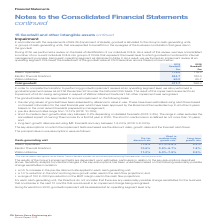According to Spirax Sarco Engineering Plc's financial document, What was consolidated as a result of the review on the basis of identification of the individual CGUs? a number of our current individual CGUs into groups of CGUs that represent the lowest level to which goodwill is monitored for internal management purposes, being each operating segment as disclosed in Note 3. The document states: "As a result of this review, we have consolidated a number of our current individual CGUs into groups of CGUs that represent the lowest level to which ..." Also, How are the carrying values of goodwill estimated? using cash flows based on forecast information for the next financial year which have been approved by the Board and then extended up to a further 9 years based on the most recent forecasts prepared by management. The document states: "erence to value in use. These have been estimated using cash flows based on forecast information for the next financial year which have been approved ..." Also, What are the different operating segment as part of the goodwill impairment reviews? The document contains multiple relevant values: Steam Specialties, Electric Thermal Solutions, Watson-Marlow. From the document: "2018 Goodwill £m Steam Specialties 113.0 119.3 Electric Thermal Solutions 244.7 183.0 Watson-Marlow 60.0 65.7 Total goodwill 417.7 368 13.0 119.3 Elec..." Additionally, In which year was the amount of Goodwill for Watson-Marlow larger? According to the financial document, 2018. The relevant text states: "2018 Goodwill £m Steam Specialties 113.0 119.3 Electric Thermal Solutions 244.7 183.0 Watson-Marlow 60.0..." Also, can you calculate: What was the change in total goodwill in 2019 from 2018? Based on the calculation: 417.7-368.0, the result is 49.7 (in millions). This is based on the information: "83.0 Watson-Marlow 60.0 65.7 Total goodwill 417.7 368.0 44.7 183.0 Watson-Marlow 60.0 65.7 Total goodwill 417.7 368.0..." The key data points involved are: 368.0, 417.7. Also, can you calculate: What was the percentage change in total goodwill in 2019 from 2018? To answer this question, I need to perform calculations using the financial data. The calculation is: (417.7-368.0)/368.0, which equals 13.51 (percentage). This is based on the information: "83.0 Watson-Marlow 60.0 65.7 Total goodwill 417.7 368.0 44.7 183.0 Watson-Marlow 60.0 65.7 Total goodwill 417.7 368.0..." The key data points involved are: 368.0, 417.7. 